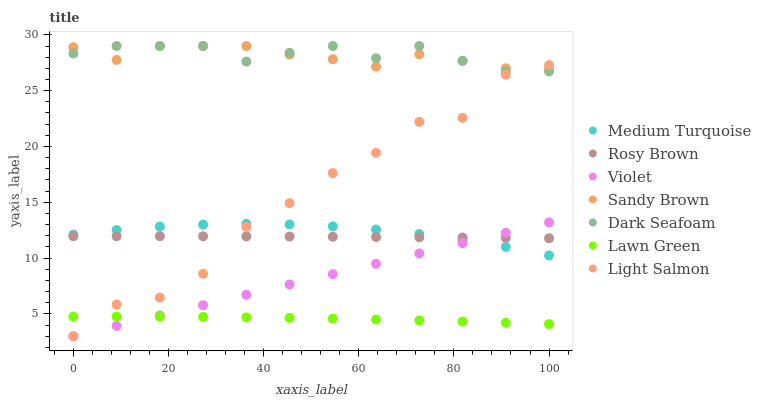Does Lawn Green have the minimum area under the curve?
Answer yes or no. Yes. Does Dark Seafoam have the maximum area under the curve?
Answer yes or no. Yes. Does Light Salmon have the minimum area under the curve?
Answer yes or no. No. Does Light Salmon have the maximum area under the curve?
Answer yes or no. No. Is Violet the smoothest?
Answer yes or no. Yes. Is Light Salmon the roughest?
Answer yes or no. Yes. Is Rosy Brown the smoothest?
Answer yes or no. No. Is Rosy Brown the roughest?
Answer yes or no. No. Does Light Salmon have the lowest value?
Answer yes or no. Yes. Does Rosy Brown have the lowest value?
Answer yes or no. No. Does Sandy Brown have the highest value?
Answer yes or no. Yes. Does Light Salmon have the highest value?
Answer yes or no. No. Is Lawn Green less than Dark Seafoam?
Answer yes or no. Yes. Is Rosy Brown greater than Lawn Green?
Answer yes or no. Yes. Does Medium Turquoise intersect Light Salmon?
Answer yes or no. Yes. Is Medium Turquoise less than Light Salmon?
Answer yes or no. No. Is Medium Turquoise greater than Light Salmon?
Answer yes or no. No. Does Lawn Green intersect Dark Seafoam?
Answer yes or no. No. 